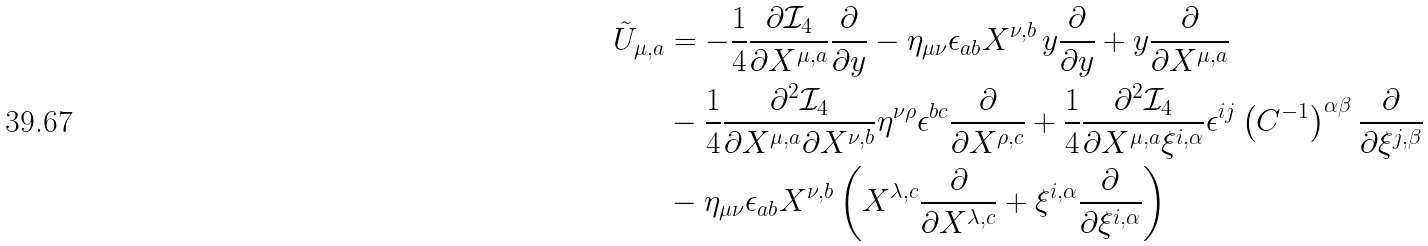Convert formula to latex. <formula><loc_0><loc_0><loc_500><loc_500>\tilde { U } _ { \mu , a } & = - \frac { 1 } { 4 } \frac { \partial \mathcal { I } _ { 4 } } { \partial X ^ { \mu , a } } \frac { \partial } { \partial y } - \eta _ { \mu \nu } \epsilon _ { a b } X ^ { \nu , b } \, y \frac { \partial } { \partial y } + y \frac { \partial } { \partial X ^ { \mu , a } } \\ & - \frac { 1 } { 4 } \frac { \partial ^ { 2 } \mathcal { I } _ { 4 } } { \partial X ^ { \mu , a } \partial X ^ { \nu , b } } \eta ^ { \nu \rho } \epsilon ^ { b c } \frac { \partial } { \partial X ^ { \rho , c } } + \frac { 1 } { 4 } \frac { \partial ^ { 2 } \mathcal { I } _ { 4 } } { \partial X ^ { \mu , a } \xi ^ { i , \alpha } } \epsilon ^ { i j } \left ( C ^ { - 1 } \right ) ^ { \alpha \beta } \frac { \partial } { \partial \xi ^ { j , \beta } } \\ & - \eta _ { \mu \nu } \epsilon _ { a b } X ^ { \nu , b } \left ( X ^ { \lambda , c } \frac { \partial } { \partial X ^ { \lambda , c } } + \xi ^ { i , \alpha } \frac { \partial } { \partial \xi ^ { i , \alpha } } \right )</formula> 